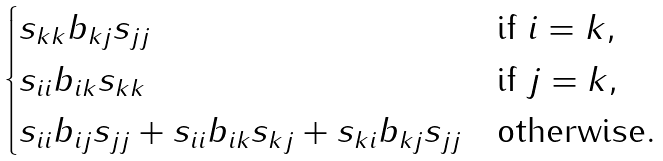Convert formula to latex. <formula><loc_0><loc_0><loc_500><loc_500>\begin{cases} s _ { k k } b _ { k j } s _ { j j } & \text {if $i = k$} , \\ s _ { i i } b _ { i k } s _ { k k } & \text {if $j = k$} , \\ s _ { i i } b _ { i j } s _ { j j } + s _ { i i } b _ { i k } s _ { k j } + s _ { k i } b _ { k j } s _ { j j } & \text {otherwise} . \end{cases}</formula> 